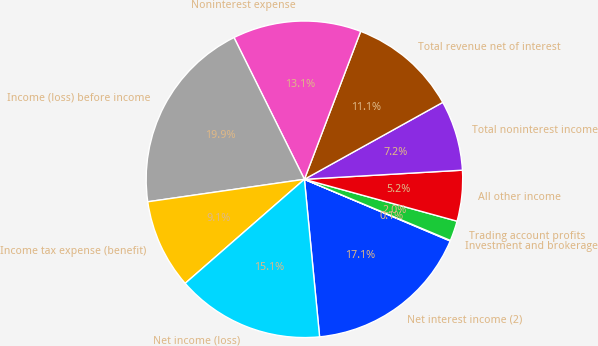Convert chart. <chart><loc_0><loc_0><loc_500><loc_500><pie_chart><fcel>Net interest income (2)<fcel>Investment and brokerage<fcel>Trading account profits<fcel>All other income<fcel>Total noninterest income<fcel>Total revenue net of interest<fcel>Noninterest expense<fcel>Income (loss) before income<fcel>Income tax expense (benefit)<fcel>Net income (loss)<nl><fcel>17.1%<fcel>0.06%<fcel>2.05%<fcel>5.18%<fcel>7.16%<fcel>11.14%<fcel>13.12%<fcel>19.93%<fcel>9.15%<fcel>15.11%<nl></chart> 